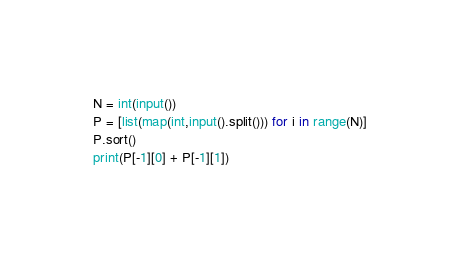<code> <loc_0><loc_0><loc_500><loc_500><_Python_>N = int(input())
P = [list(map(int,input().split())) for i in range(N)]
P.sort()
print(P[-1][0] + P[-1][1])</code> 